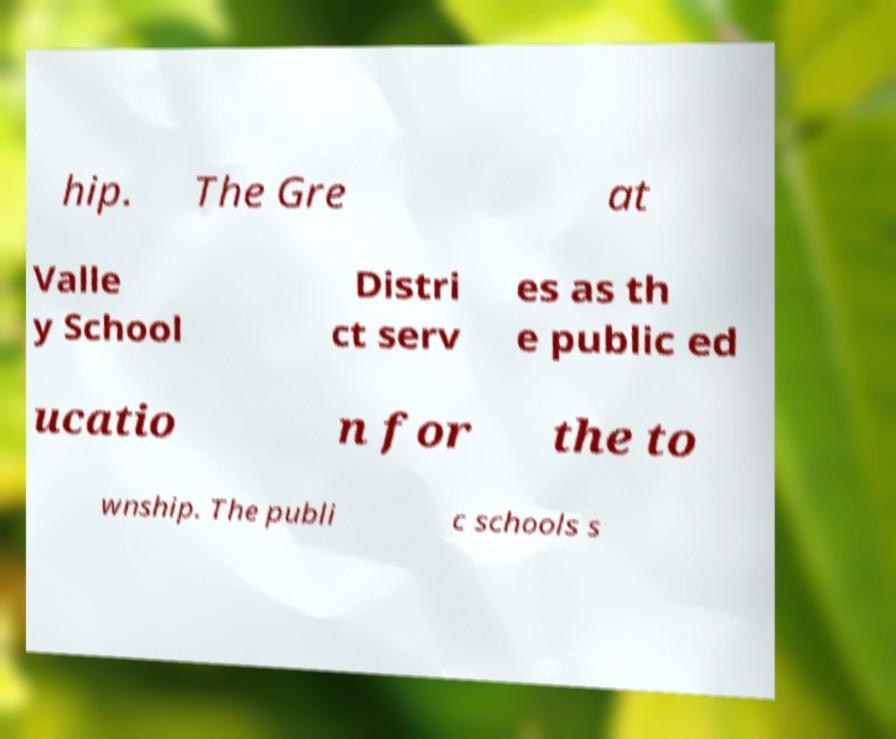Can you read and provide the text displayed in the image?This photo seems to have some interesting text. Can you extract and type it out for me? hip. The Gre at Valle y School Distri ct serv es as th e public ed ucatio n for the to wnship. The publi c schools s 